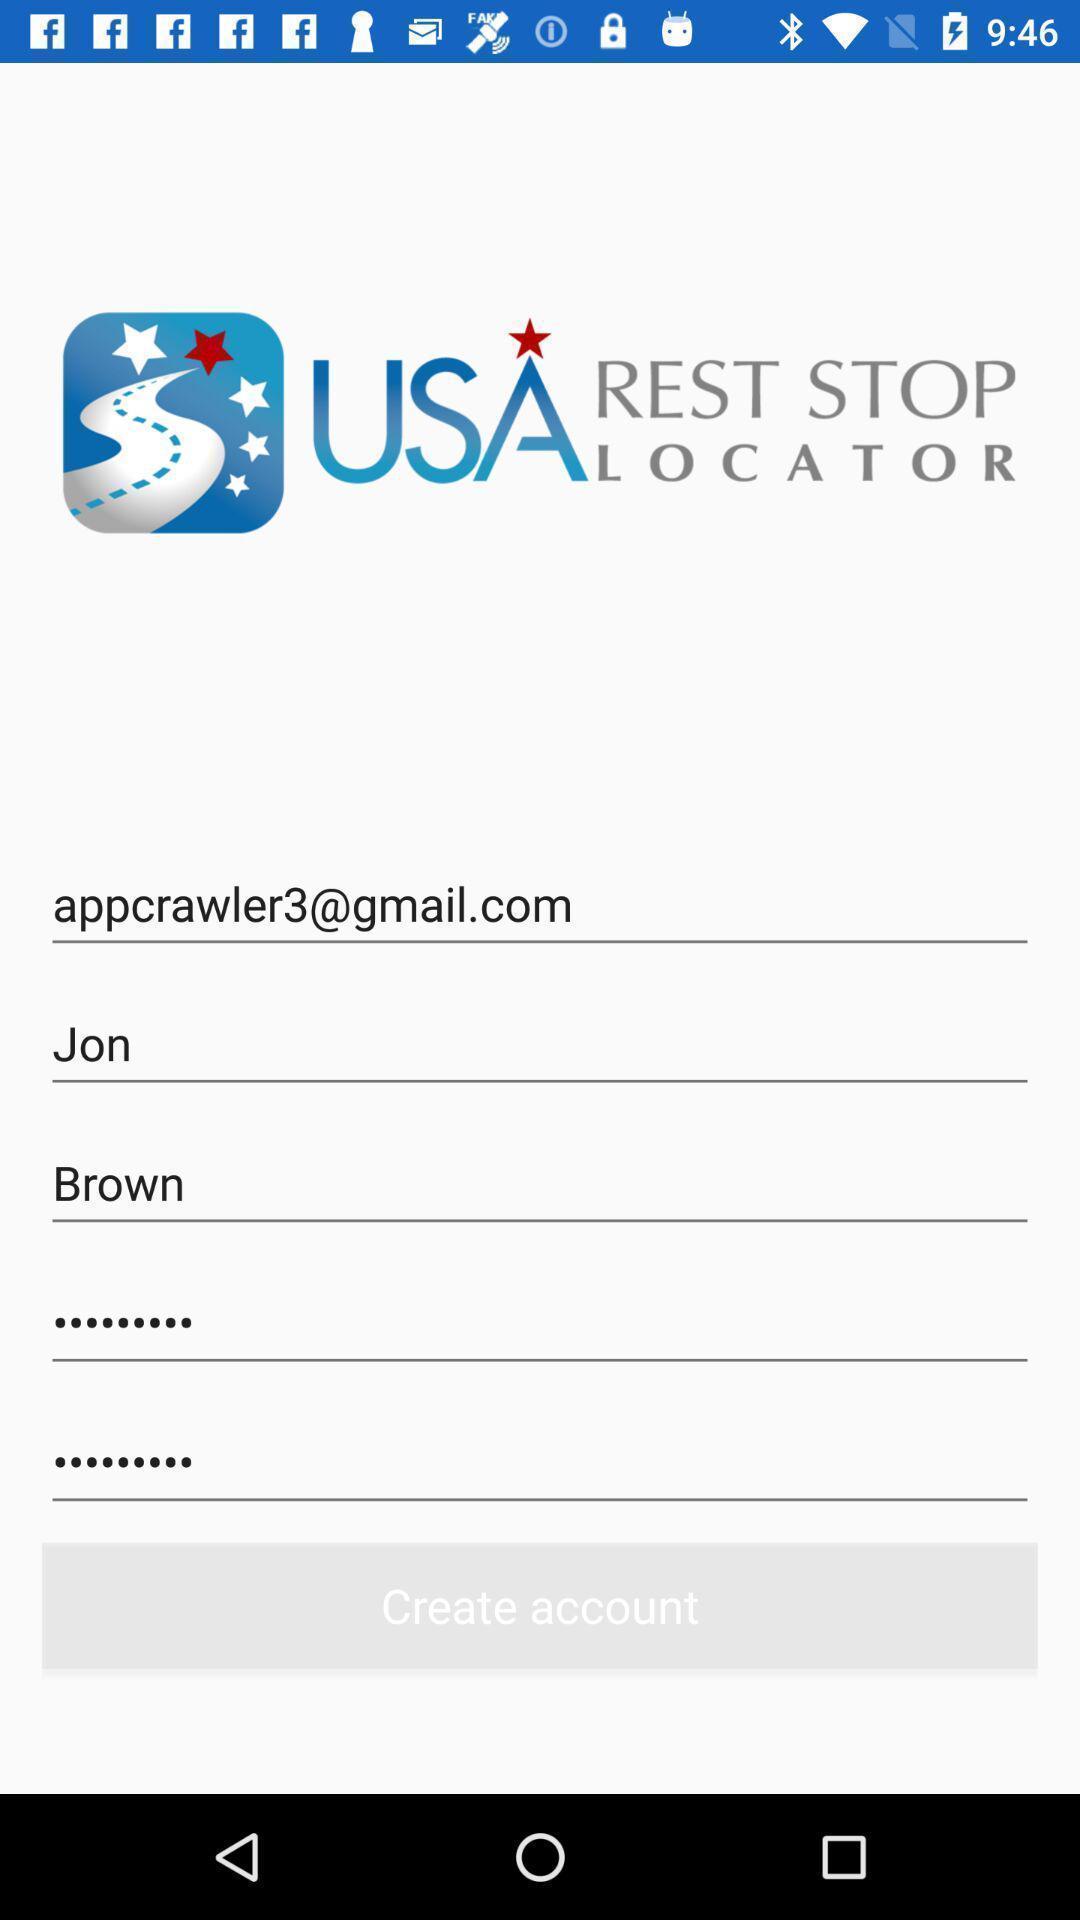Describe the visual elements of this screenshot. Startup page with text boxes to enter your profile details. 